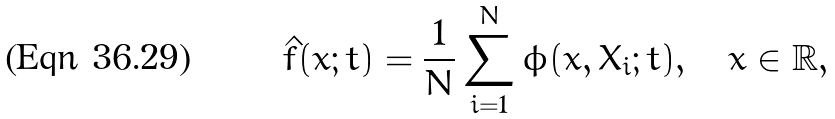<formula> <loc_0><loc_0><loc_500><loc_500>\hat { f } ( x ; t ) = \frac { 1 } { N } \sum _ { i = 1 } ^ { N } \phi ( x , X _ { i } ; t ) , \quad x \in \mathbb { R } ,</formula> 